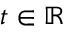<formula> <loc_0><loc_0><loc_500><loc_500>t \in \mathbb { R }</formula> 